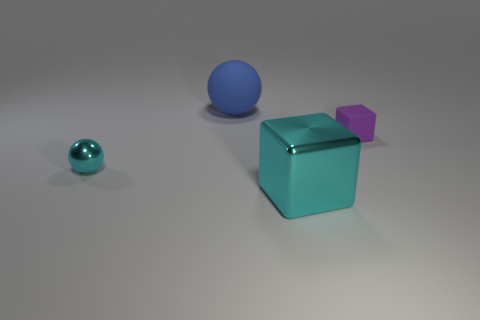Add 3 small purple matte objects. How many objects exist? 7 Subtract 1 cubes. How many cubes are left? 1 Subtract all cyan balls. How many balls are left? 1 Subtract all tiny cyan spheres. Subtract all tiny purple rubber things. How many objects are left? 2 Add 4 cyan metallic spheres. How many cyan metallic spheres are left? 5 Add 4 large brown matte cubes. How many large brown matte cubes exist? 4 Subtract 0 gray blocks. How many objects are left? 4 Subtract all blue cubes. Subtract all purple balls. How many cubes are left? 2 